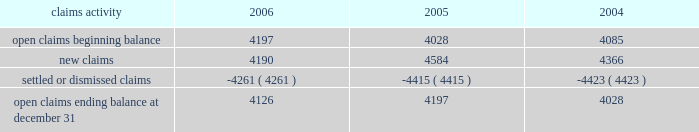Potentially responsible parties , and existing technology , laws , and regulations .
The ultimate liability for remediation is difficult to determine because of the number of potentially responsible parties involved , site- specific cost sharing arrangements with other potentially responsible parties , the degree of contamination by various wastes , the scarcity and quality of volumetric data related to many of the sites , and the speculative nature of remediation costs .
Current obligations are not expected to have a material adverse effect on our consolidated results of operations , financial condition , or liquidity .
Personal injury 2013 the cost of personal injuries to employees and others related to our activities is charged to expense based on estimates of the ultimate cost and number of incidents each year .
We use third-party actuaries to assist us with measuring the expense and liability , including unasserted claims .
The federal employers 2019 liability act ( fela ) governs compensation for work-related accidents .
Under fela , damages are assessed based on a finding of fault through litigation or out-of-court settlements .
We offer a comprehensive variety of services and rehabilitation programs for employees who are injured at work .
Annual expenses for personal injury-related events were $ 240 million in 2006 , $ 247 million in 2005 , and $ 288 million in 2004 .
As of december 31 , 2006 and 2005 , we had accrued liabilities of $ 631 million and $ 619 million for future personal injury costs , respectively , of which $ 233 million and $ 274 million was recorded in current liabilities as accrued casualty costs , respectively .
Our personal injury liability is discounted to present value using applicable u.s .
Treasury rates .
Approximately 87% ( 87 % ) of the recorded liability related to asserted claims , and approximately 13% ( 13 % ) related to unasserted claims .
Estimates can vary over time due to evolving trends in litigation .
Our personal injury claims activity was as follows : claims activity 2006 2005 2004 .
Depreciation 2013 the railroad industry is capital intensive .
Properties are carried at cost .
Provisions for depreciation are computed principally on the straight-line method based on estimated service lives of depreciable property .
The lives are calculated using a separate composite annual percentage rate for each depreciable property group , based on the results of internal depreciation studies .
We are required to submit a report on depreciation studies and proposed depreciation rates to the stb for review and approval every three years for equipment property and every six years for road property .
The cost ( net of salvage ) of depreciable railroad property retired or replaced in the ordinary course of business is charged to accumulated depreciation , and no gain or loss is recognized .
A gain or loss is recognized in other income for all other property upon disposition because the gain or loss is not part of rail operations .
The cost of internally developed software is capitalized and amortized over a five-year period .
Significant capital spending in recent years increased the total value of our depreciable assets .
Cash capital spending totaled $ 2.2 billion for the year ended december 31 , 2006 .
For the year ended december 31 , 2006 , depreciation expense was $ 1.2 billion .
We use various methods to estimate useful lives for each group of depreciable property .
Due to the capital intensive nature of the business and the large base of depreciable assets , variances to those estimates could have a material effect on our consolidated financial statements .
If the estimated useful lives of all depreciable assets were increased by one year , annual depreciation expense would decrease by approximately $ 43 million .
If the estimated useful lives of all assets to be depreciated were decreased by one year , annual depreciation expense would increase by approximately $ 45 million .
Income taxes 2013 as required under fasb statement no .
109 , accounting for income taxes , we account for income taxes by recording taxes payable or refundable for the current year and deferred tax assets and liabilities for the future tax consequences of events that have been recognized in our financial statements or tax returns .
These .
What was the percentage increase in the open claims ending balance at december 312005 from 2004? 
Computations: ((4197 - 4028) / 4028)
Answer: 0.04196. 